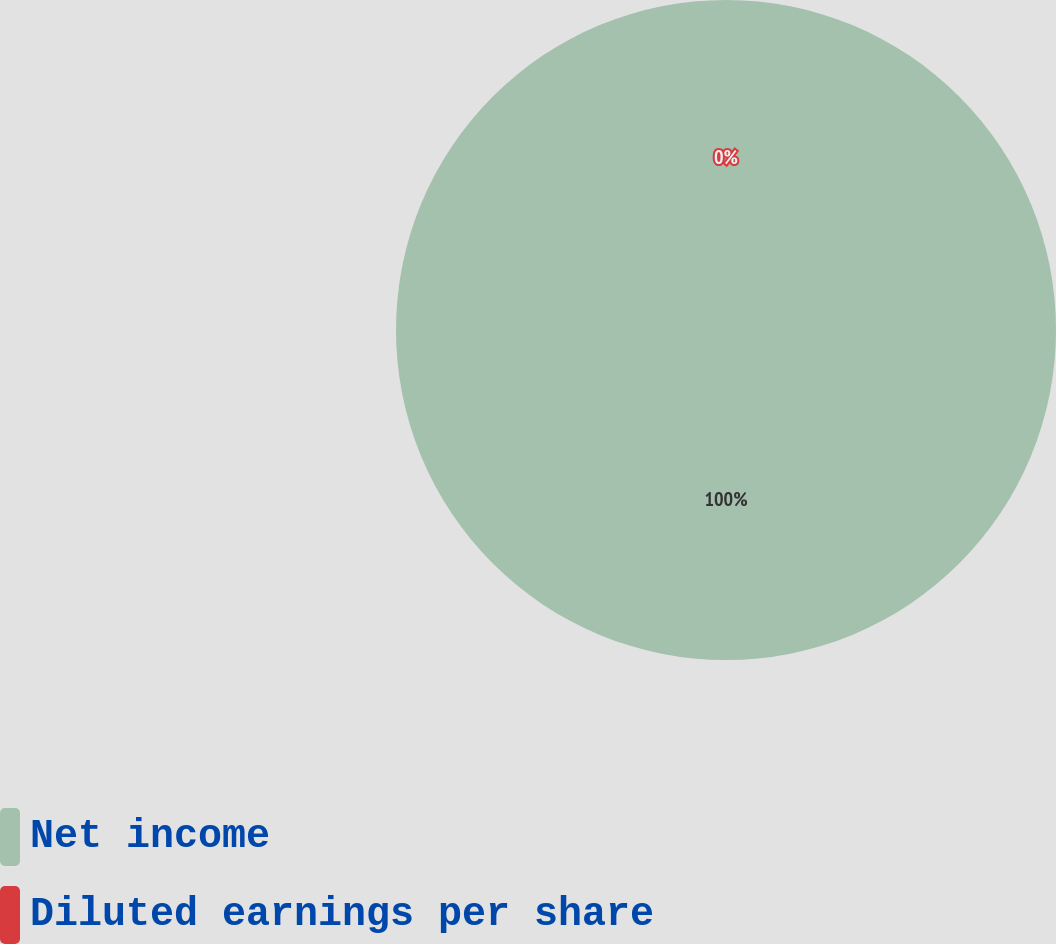Convert chart. <chart><loc_0><loc_0><loc_500><loc_500><pie_chart><fcel>Net income<fcel>Diluted earnings per share<nl><fcel>100.0%<fcel>0.0%<nl></chart> 